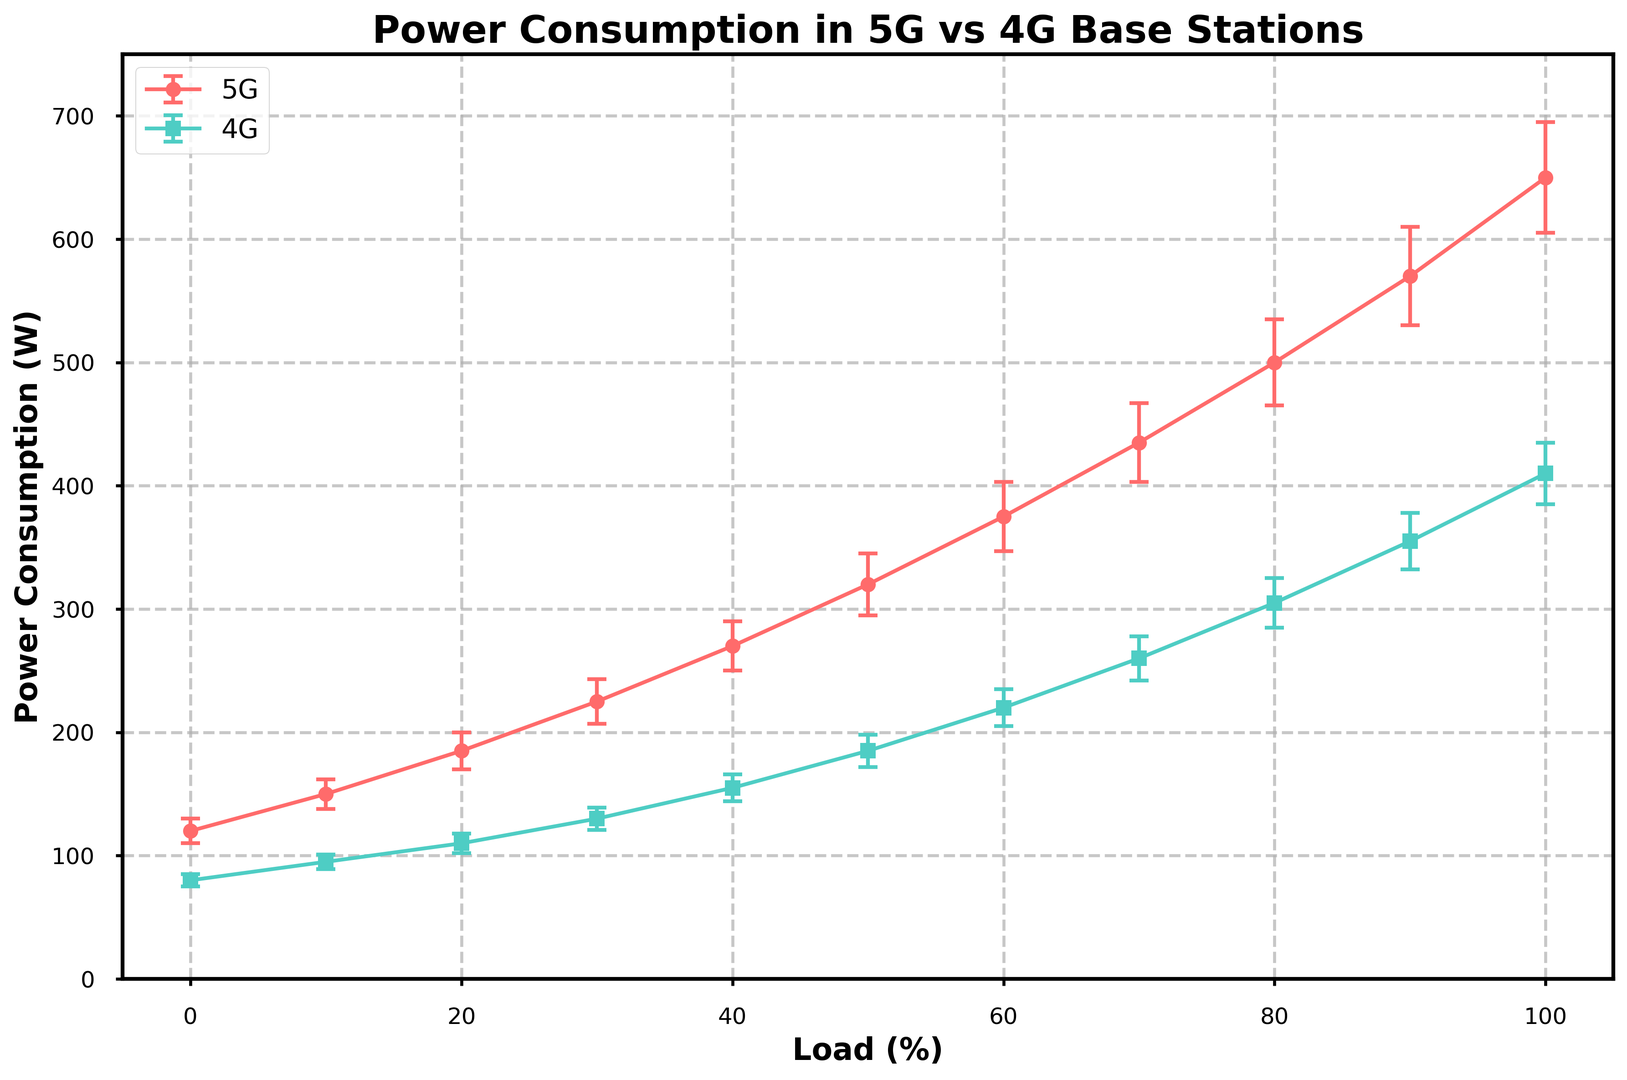What is the power consumption for 5G at 50% load? The 5G power consumption at 50% load can be directly read from the figure, where the x-axis corresponds to the load and the y-axis to the power consumption.
Answer: 320 W Compare the power consumption of 5G and 4G at 100% load. Which one is higher and by how much? By looking at the endpoints of both lines at 100% load on the x-axis, the 5G power consumption is 650 W and the 4G is 410 W. The difference between them is 650 - 410.
Answer: 5G is higher by 240 W Which line shows steeper increase in power consumption as the load increases from 0% to 100%? Steeper increase corresponds to a larger gradient. The 5G line rises from 120 W to 650 W, and the 4G line rises from 80 W to 410 W. The total increase for 5G is 530 W and for 4G is 330 W. Therefore, 5G shows a steeper increase.
Answer: 5G What is the average power consumption of 5G over all load conditions? To find the average power consumption, sum all the 5G power values and divide by the number of data points: (120 + 150 + 185 + 225 + 270 + 320 + 375 + 435 + 500 + 570 + 650) / 11.
Answer: 346.36 W At which load percentage do both 5G and 4G have the smallest error in power measurements? Error bars represent the uncertainty in the power measurements. By comparing the lengths of error bars visually, the smallest ones are at 0% load: 5G error = ±10 W and 4G error = ±5 W.
Answer: 0% How does the power consumption difference between 5G and 4G change as the load increases from 70% to 80%? For 70% load: 5G power - 4G power = 435 - 260 = 175 W. For 80% load: 5G power - 4G power = 500 - 305 = 195 W. Difference: 195 - 175 = 20 W increase.
Answer: Increase by 20 W At what load percentage is the difference between 5G and 4G power consumption the highest? Calculate the differences at each load point: 120-80, 150-95, 185-110, 225-130, 270-155, 320-185, 375-220, 435-260, 500-305, 570-355, 650-410. The highest difference is at 100% load: 650 - 410 = 240 W.
Answer: 100% Which load condition has the highest relative error for 5G power measurements? Relative error is calculated as (Error / Power) * 100. Compute for each load percentage: (10/120, 12/150, 15/185, etc.), the highest relative error is at 0% load: (10/120) * 100 ≈ 8.33%.
Answer: 0% Compare the shapes of the error bars between 5G and 4G. Which one generally has larger error bars? Visually inspect the lengths of the error bars, 5G consistently has larger error bars than 4G across all load conditions.
Answer: 5G What is the overall trend observed in power consumption for both 5G and 4G base stations as load increases? Both the 5G and 4G lines show an upward trend, indicating that power consumption increases with increasing load. The 5G increase is more pronounced than 4G.
Answer: Increase 